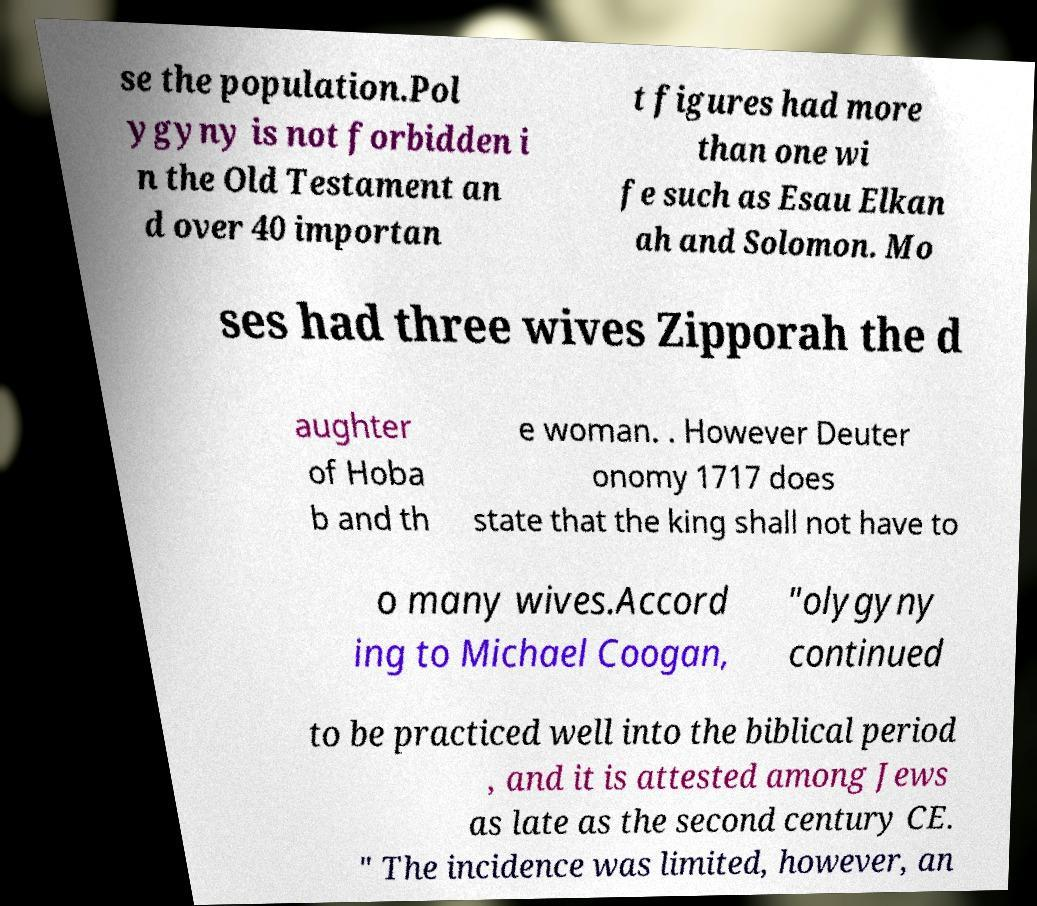Please identify and transcribe the text found in this image. se the population.Pol ygyny is not forbidden i n the Old Testament an d over 40 importan t figures had more than one wi fe such as Esau Elkan ah and Solomon. Mo ses had three wives Zipporah the d aughter of Hoba b and th e woman. . However Deuter onomy 1717 does state that the king shall not have to o many wives.Accord ing to Michael Coogan, "olygyny continued to be practiced well into the biblical period , and it is attested among Jews as late as the second century CE. " The incidence was limited, however, an 